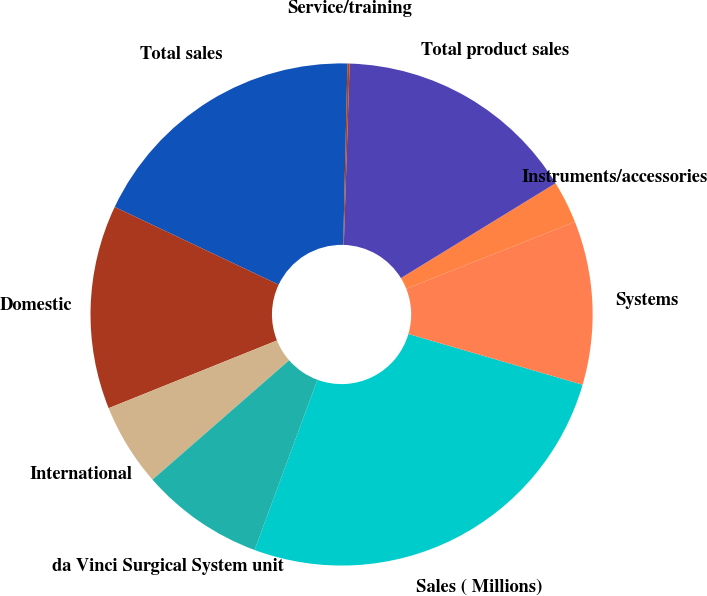Convert chart to OTSL. <chart><loc_0><loc_0><loc_500><loc_500><pie_chart><fcel>Sales ( Millions)<fcel>Systems<fcel>Instruments/accessories<fcel>Total product sales<fcel>Service/training<fcel>Total sales<fcel>Domestic<fcel>International<fcel>da Vinci Surgical System unit<nl><fcel>26.12%<fcel>10.53%<fcel>2.74%<fcel>15.73%<fcel>0.14%<fcel>18.33%<fcel>13.13%<fcel>5.34%<fcel>7.94%<nl></chart> 